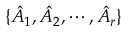<formula> <loc_0><loc_0><loc_500><loc_500>\{ \hat { A } _ { 1 } , \hat { A } _ { 2 } , \cdots , \hat { A } _ { r } \}</formula> 